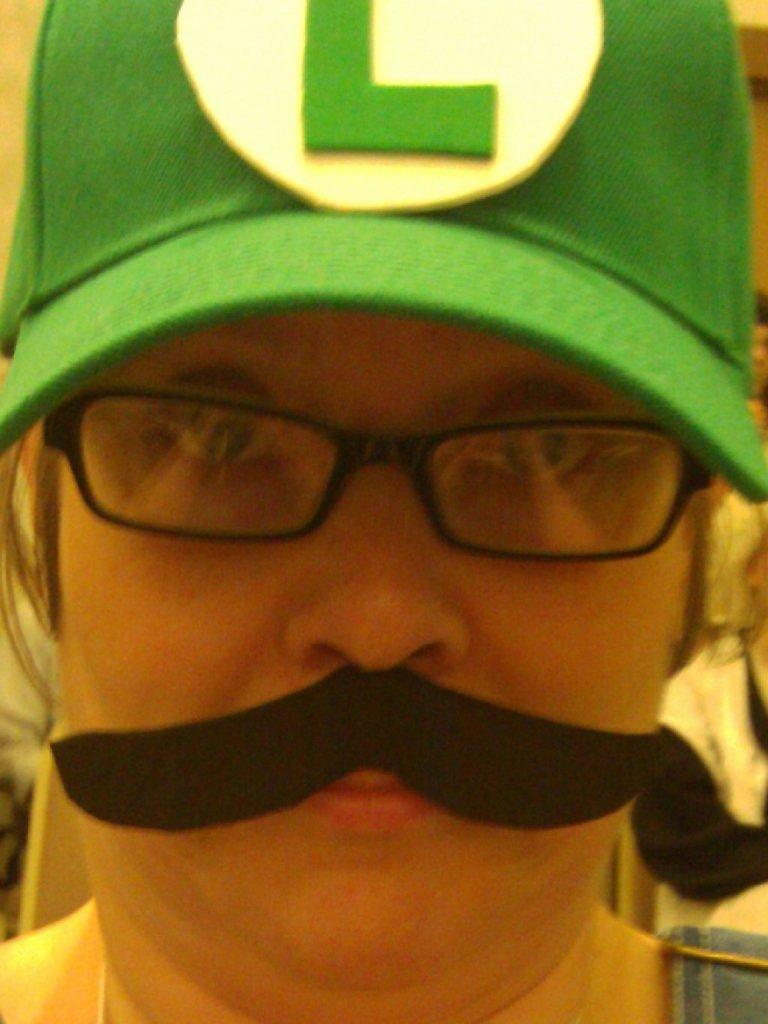What is the person in the image wearing on their face? The person is wearing spectacles. What type of headwear is the person wearing? The person is wearing a green cap. What type of weather condition is present in the image? There is no information about the weather in the image. What hobbies does the person in the image have? There is no information about the person's hobbies in the image. 